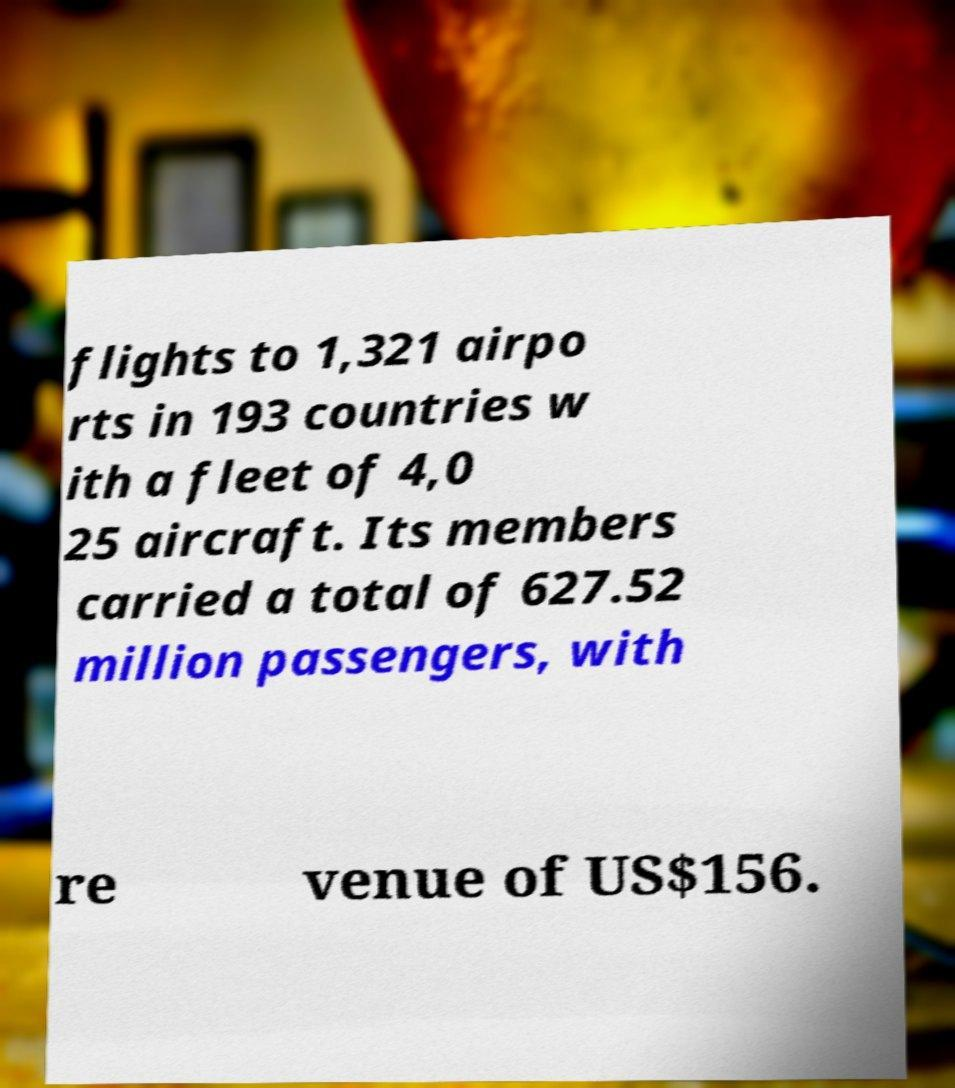What messages or text are displayed in this image? I need them in a readable, typed format. flights to 1,321 airpo rts in 193 countries w ith a fleet of 4,0 25 aircraft. Its members carried a total of 627.52 million passengers, with re venue of US$156. 